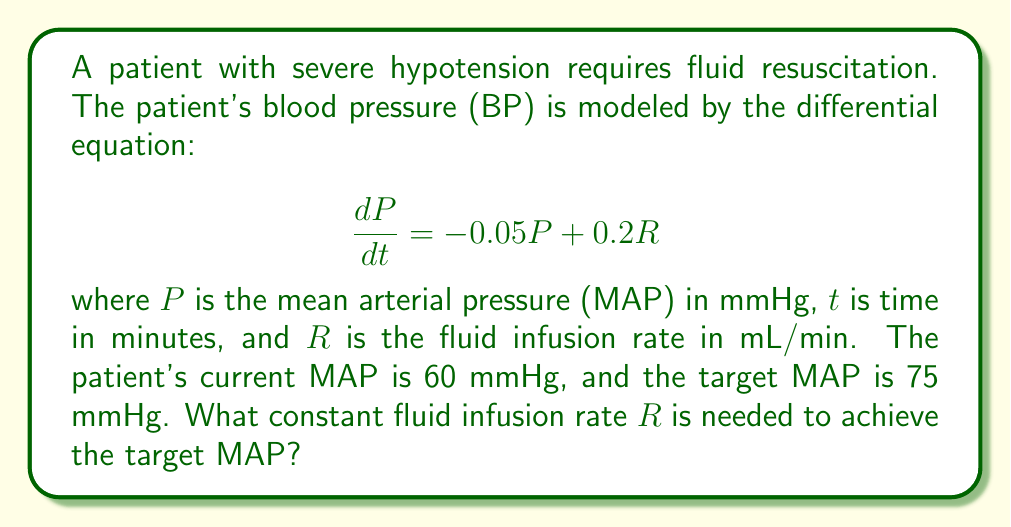Could you help me with this problem? To solve this problem, we need to follow these steps:

1) At steady state, when the target MAP is achieved, $\frac{dP}{dt} = 0$. So we can write:

   $$0 = -0.05P + 0.2R$$

2) We want $P = 75$ mmHg (the target MAP). Substituting this:

   $$0 = -0.05(75) + 0.2R$$

3) Solve for $R$:

   $$0.2R = 0.05(75)$$
   $$0.2R = 3.75$$
   $$R = \frac{3.75}{0.2} = 18.75$$

4) Therefore, a constant fluid infusion rate of 18.75 mL/min is needed to maintain the target MAP of 75 mmHg.

5) To verify, we can check if this infusion rate will lead to a steady state at 75 mmHg:

   $$\frac{dP}{dt} = -0.05(75) + 0.2(18.75) = -3.75 + 3.75 = 0$$

   This confirms that 75 mmHg is indeed the steady state MAP for this infusion rate.
Answer: The required constant fluid infusion rate is 18.75 mL/min. 